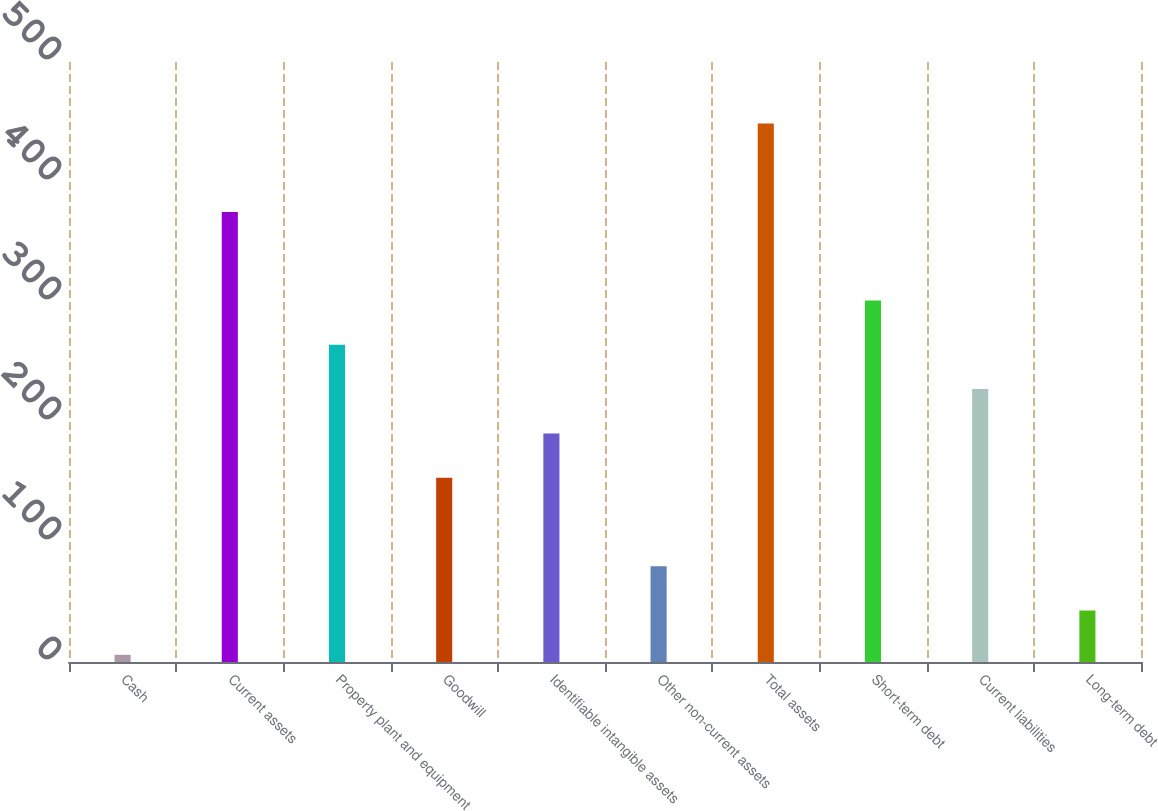<chart> <loc_0><loc_0><loc_500><loc_500><bar_chart><fcel>Cash<fcel>Current assets<fcel>Property plant and equipment<fcel>Goodwill<fcel>Identifiable intangible assets<fcel>Other non-current assets<fcel>Total assets<fcel>Short-term debt<fcel>Current liabilities<fcel>Long-term debt<nl><fcel>6<fcel>375<fcel>264.3<fcel>153.6<fcel>190.5<fcel>79.8<fcel>448.8<fcel>301.2<fcel>227.4<fcel>42.9<nl></chart> 